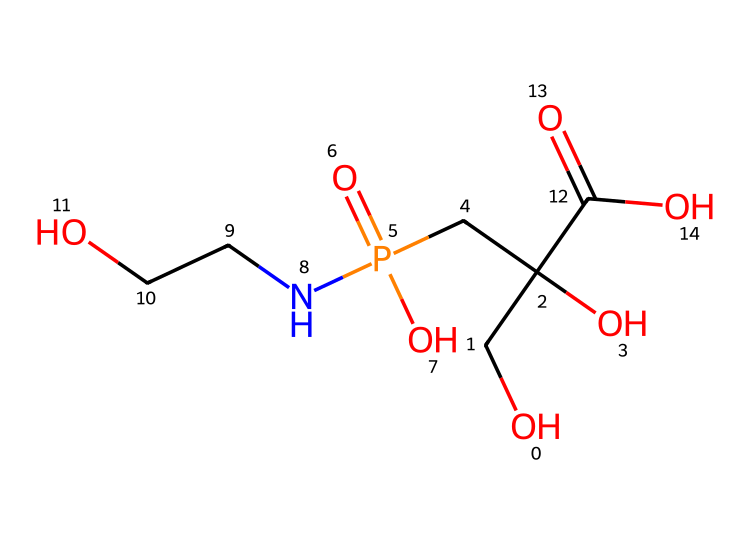what is the molecular formula of glyphosate? To determine the molecular formula, count the number of each type of atom present in the SMILES representation. The structure contains: Carbon (C), Hydrogen (H), Oxygen (O), and Nitrogen (N) atoms. Specifically, there are 3 Carbons, 11 Hydrogens, 4 Oxygens, and 1 Nitrogen. Therefore, the molecular formula is C3H11N2O4P.
Answer: C3H11N2O4P how many carbon atoms are in the glyphosate molecule? Counting the number of 'C' in the explored structure, we see there are three 'C' atoms present in glyphosate.
Answer: 3 which functional group is present in glyphosate? Identifying the functional groups in the structure based on the components visible in the SMILES: The molecule has a carboxylic acid functional group (-COOH) at one end and a phosphate group, as seen by the presence of 'P' and multiple 'O's. Therefore, the primary functional group is the carboxylic acid.
Answer: carboxylic acid what is the total number of oxygen atoms in glyphosate? By examining the SMILES representation, we find there are four oxygen atoms 'O' in total throughout the entire molecule.
Answer: 4 is glyphosate a broad-spectrum herbicide? Glyphosate is designed to target a wide variety of plants, thus it is classified as a broad-spectrum herbicide.
Answer: yes what is the significance of the nitrogen atom in the glyphosate structure? The presence of the nitrogen atom indicates that glyphosate is an amine-containing compound which contributes to its herbicidal properties by influencing how it interacts with plant biochemistry.
Answer: herbicidal properties 